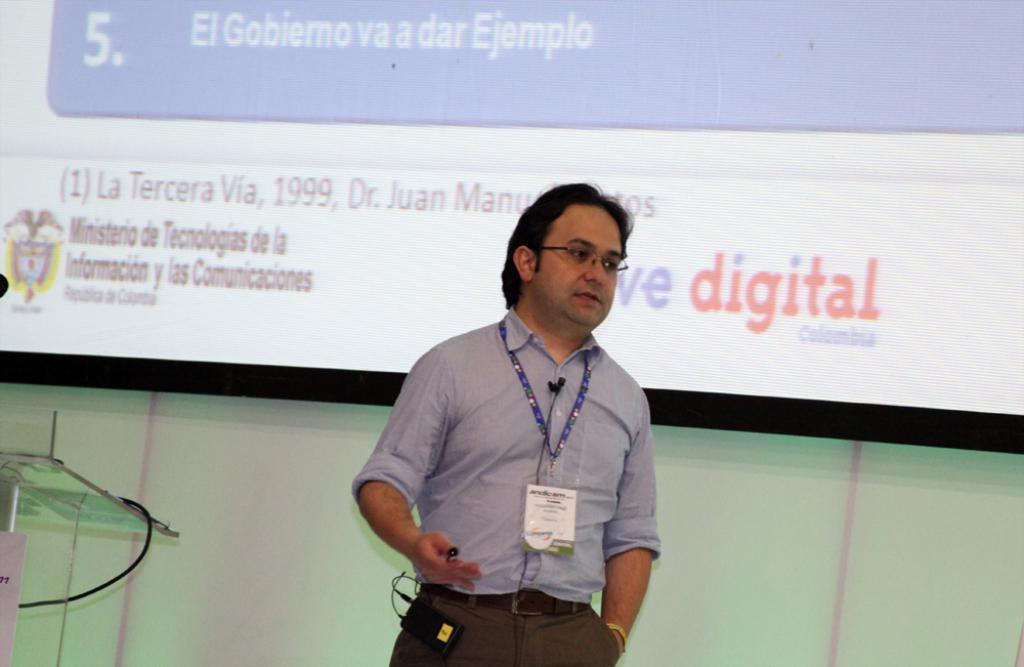In one or two sentences, can you explain what this image depicts? In this picture we can see the man wearing a blue shirt and standing in the front with an identity card. Behind there is a white projector screen.  